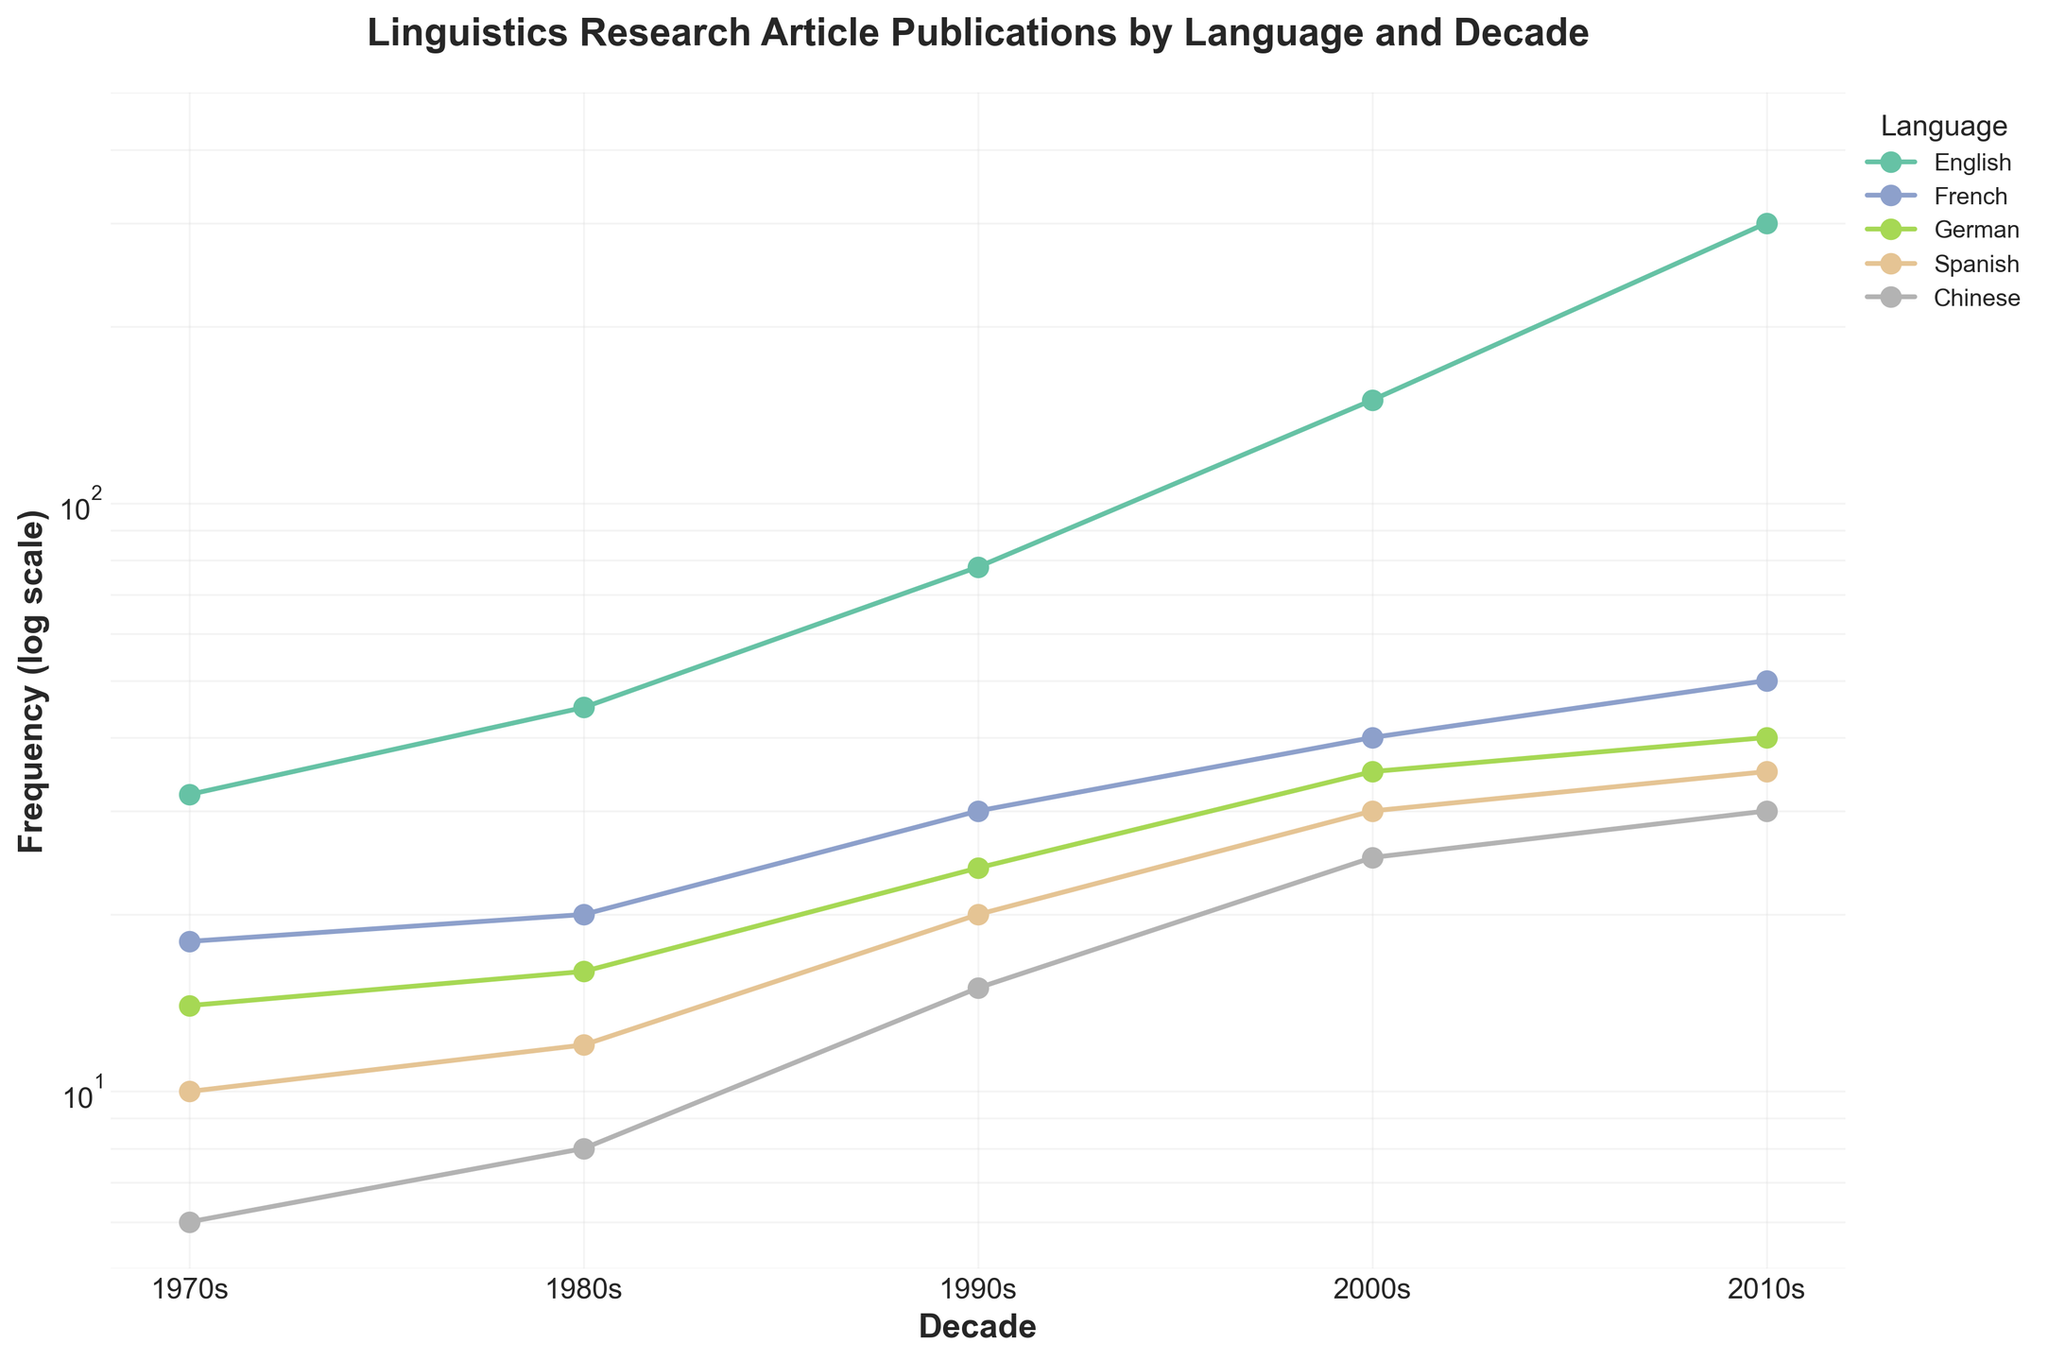What is the title of the figure? The title is typically displayed at the top of the figure. In this case, it reads, "Linguistics Research Article Publications by Language and Decade."
Answer: Linguistics Research Article Publications by Language and Decade How is the y-axis scaled in the figure? The y-axis scaling is mentioned to be in log scale as specified in the code. This can be observed by noticing the axis label which reads "Frequency (log scale)."
Answer: Log scale Which language had the highest frequency of publication in the 2000s? By observing the data points for each language in the 2000s, the line with the highest point belongs to English, which reaches 150.
Answer: English In which decade did Chinese articles have their highest frequency? Tracking the Chinese line across the decades, it is evident that the highest point is in the 2010s with a frequency value of 30.
Answer: 2010s Is the publication frequency of German articles in the 2010s greater than or less than the frequency in the 2000s? Comparing the German data points, the frequency increases from 35 in the 2000s to 40 in the 2010s. Thus, it is greater.
Answer: Greater What is the sum of the frequencies for French publications across all decades? Sum the French data points from the 1970s to the 2010s: 18 + 20 + 30 + 40 + 50 = 158.
Answer: 158 By what factor did the frequency of Spanish publications in the 2010s compare to the 1970s? Calculate the factor by dividing the 2010s value by the 1970s value: 35 / 10 = 3.5.
Answer: 3.5 Which language shows the steepest increase in publication frequency from the 1970s to the 2010s? Observing the slopes of all lines from the 1970s to the 2010s, English shows the most dramatic increase from 32 to 300.
Answer: English On average, how many articles were published in Spanish per decade? Sum the Spanish frequencies and divide by the number of decades: (10 + 12 + 20 + 30 + 35)/5 = 21.4.
Answer: 21.4 Between French and Chinese articles, which had a larger percentage increase from the 1980s to the 1990s? For French: [(30 - 20) / 20] * 100 = 50%. For Chinese: [(15 - 8) / 8] * 100 = 87.5%. Thus, Chinese had a larger percentage increase.
Answer: Chinese 